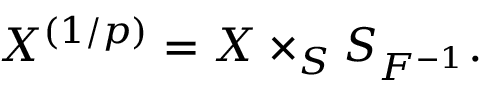Convert formula to latex. <formula><loc_0><loc_0><loc_500><loc_500>X ^ { ( 1 / p ) } = X \times _ { S } S _ { F ^ { - 1 } } .</formula> 